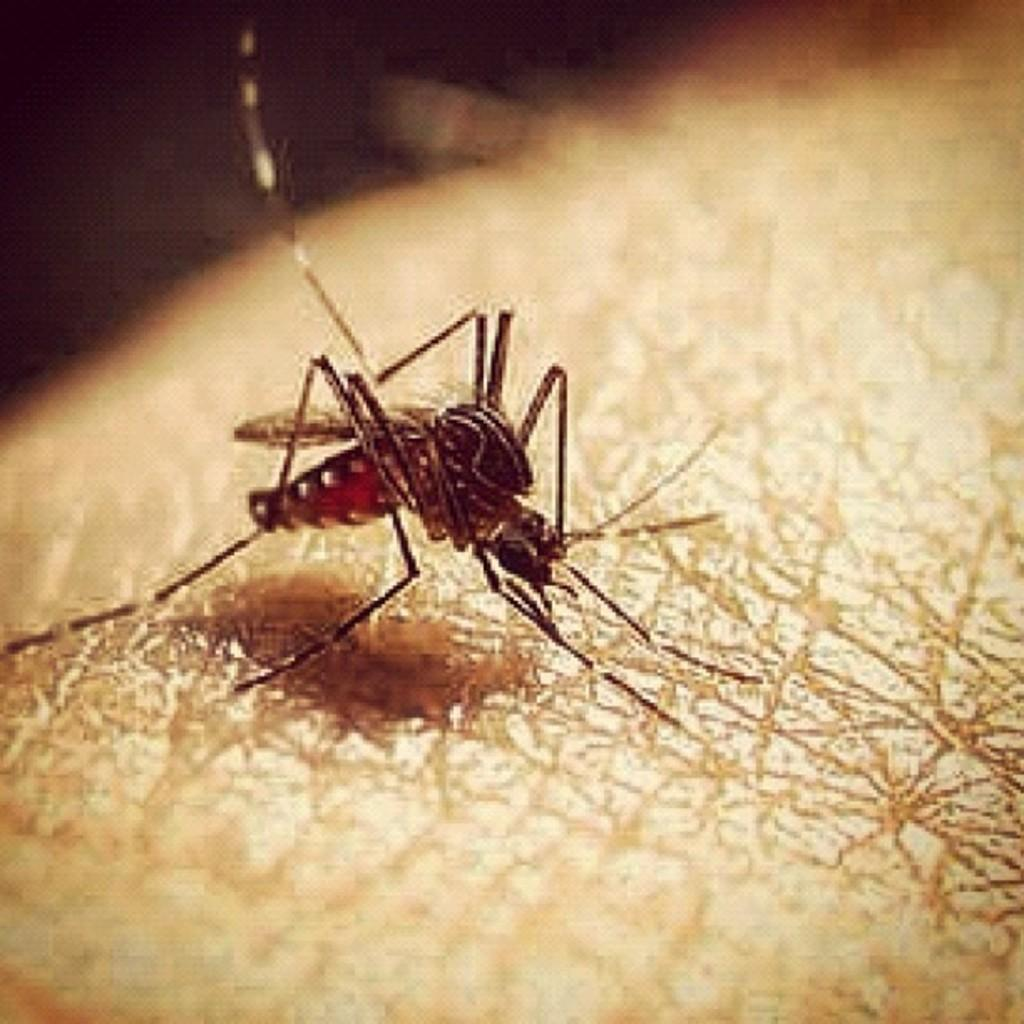What is the main subject of the image? The main subject of the image is a mosquito. Where is the mosquito located in the image? The mosquito is on a path in the image. What can be observed about the background of the image? The background of the image is dark. What type of slip is your uncle wearing in the image? There is no uncle or slip present in the image; it only features a mosquito on a path with a dark background. 